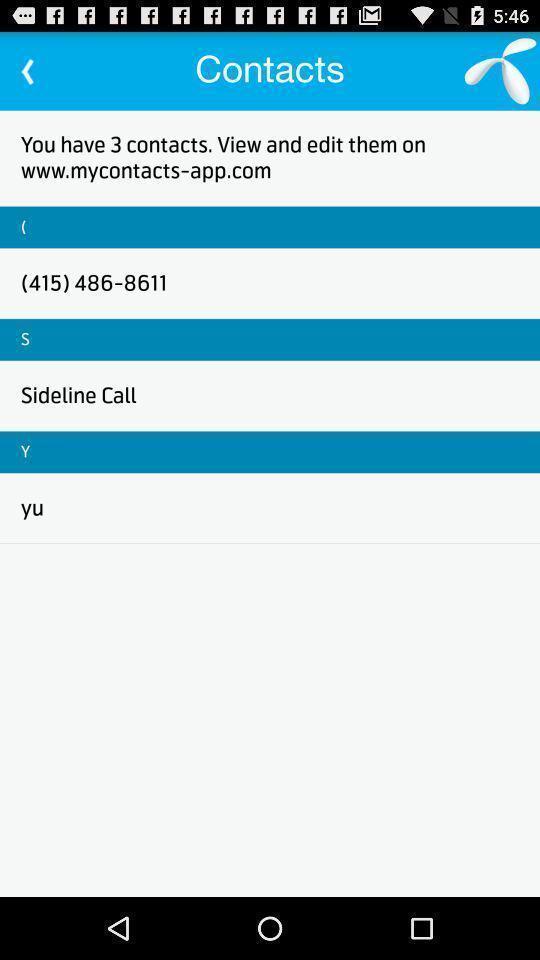Provide a description of this screenshot. Screen shows contacts to edit. 